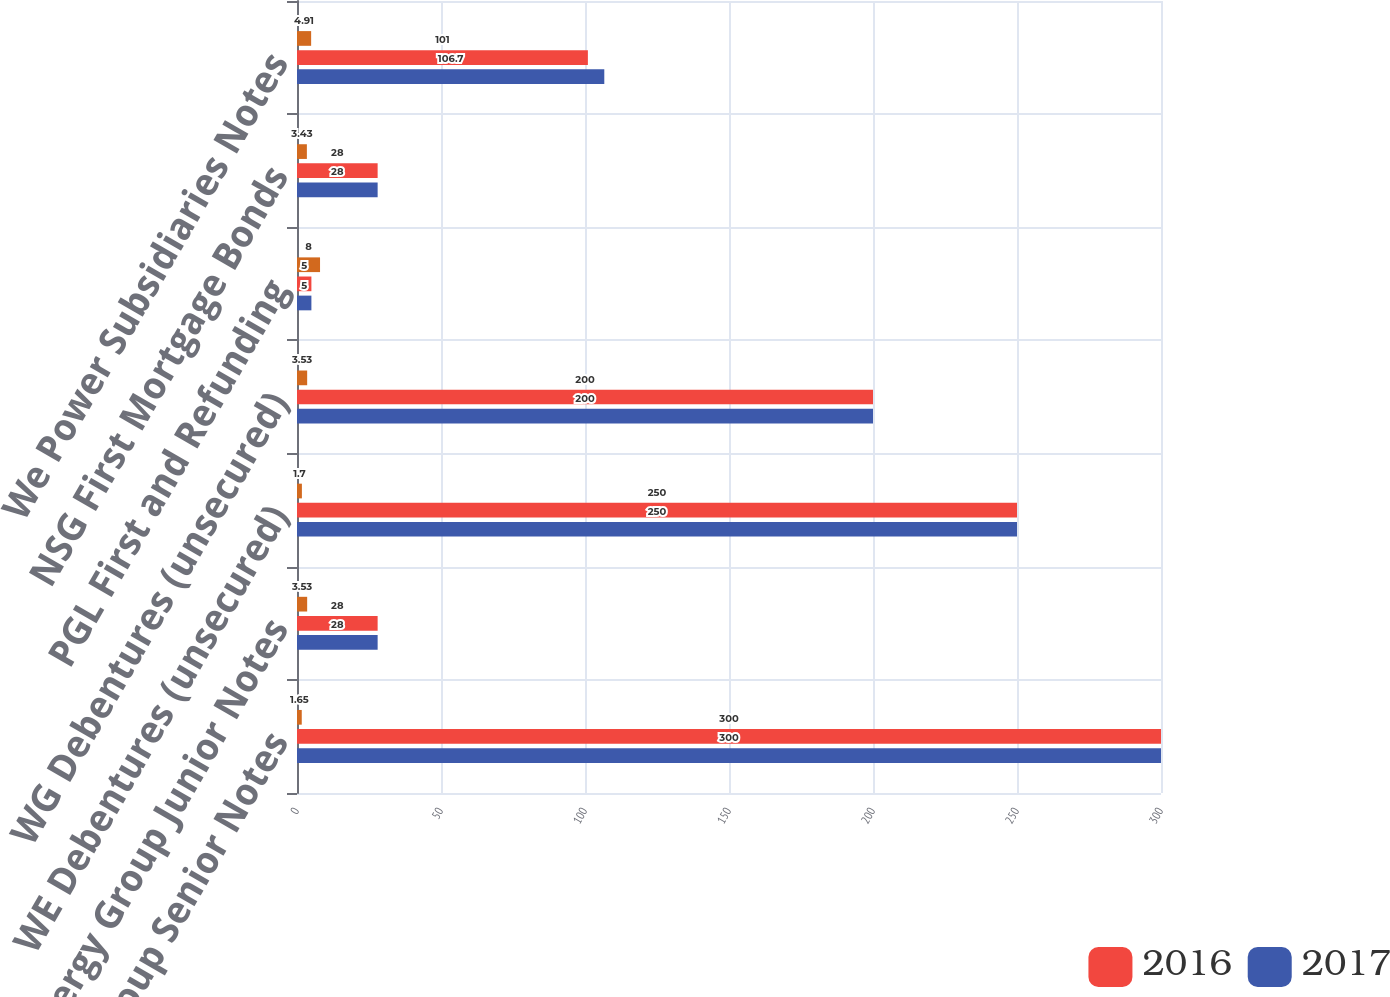<chart> <loc_0><loc_0><loc_500><loc_500><stacked_bar_chart><ecel><fcel>WEC Energy Group Senior Notes<fcel>WEC Energy Group Junior Notes<fcel>WE Debentures (unsecured)<fcel>WG Debentures (unsecured)<fcel>PGL First and Refunding<fcel>NSG First Mortgage Bonds<fcel>We Power Subsidiaries Notes<nl><fcel>nan<fcel>1.65<fcel>3.53<fcel>1.7<fcel>3.53<fcel>8<fcel>3.43<fcel>4.91<nl><fcel>2016<fcel>300<fcel>28<fcel>250<fcel>200<fcel>5<fcel>28<fcel>101<nl><fcel>2017<fcel>300<fcel>28<fcel>250<fcel>200<fcel>5<fcel>28<fcel>106.7<nl></chart> 